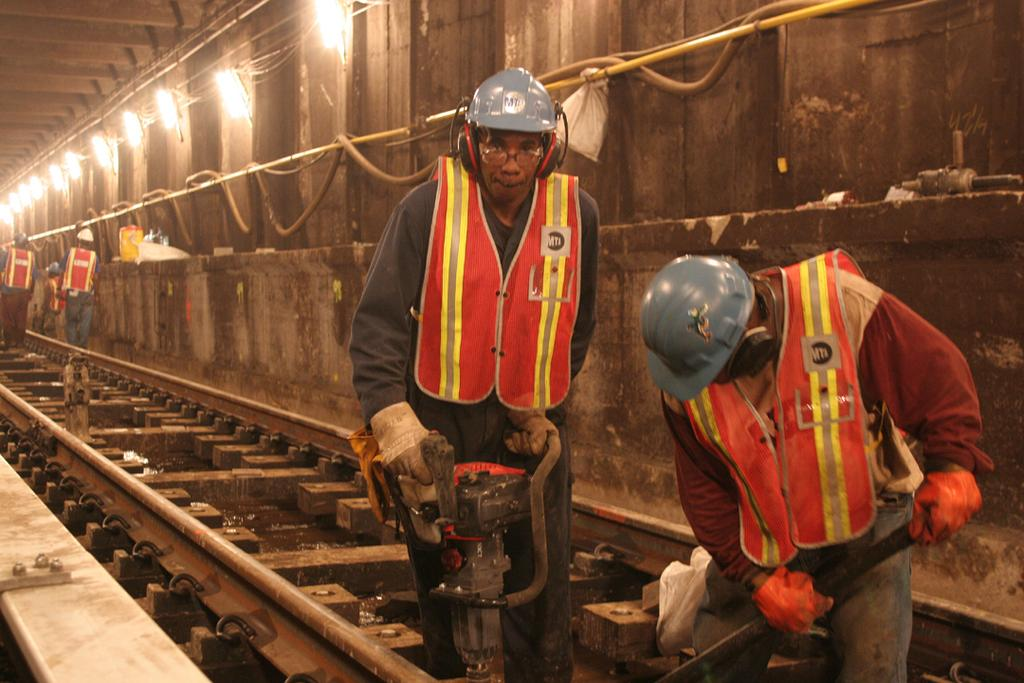What is the man in the image doing? The man in the image is drilling the railway track. On which side of the image is the man located? The man is on the right side of the image. What is the man wearing on his upper body? The man is wearing an orange jacket. What type of head protection is the man wearing? The man is wearing a blue helmet. What can be seen on the left side of the image? There are lights on the wall on the left side of the image. What is the main subject of the image? The main subject of the image is the man drilling the railway track. What type of property is being sold in the image? There is no indication of a property being sold in the image; it features a man drilling a railway track. What riddle can be solved by looking at the image? There is no riddle present in the image; it simply shows a man drilling a railway track. 